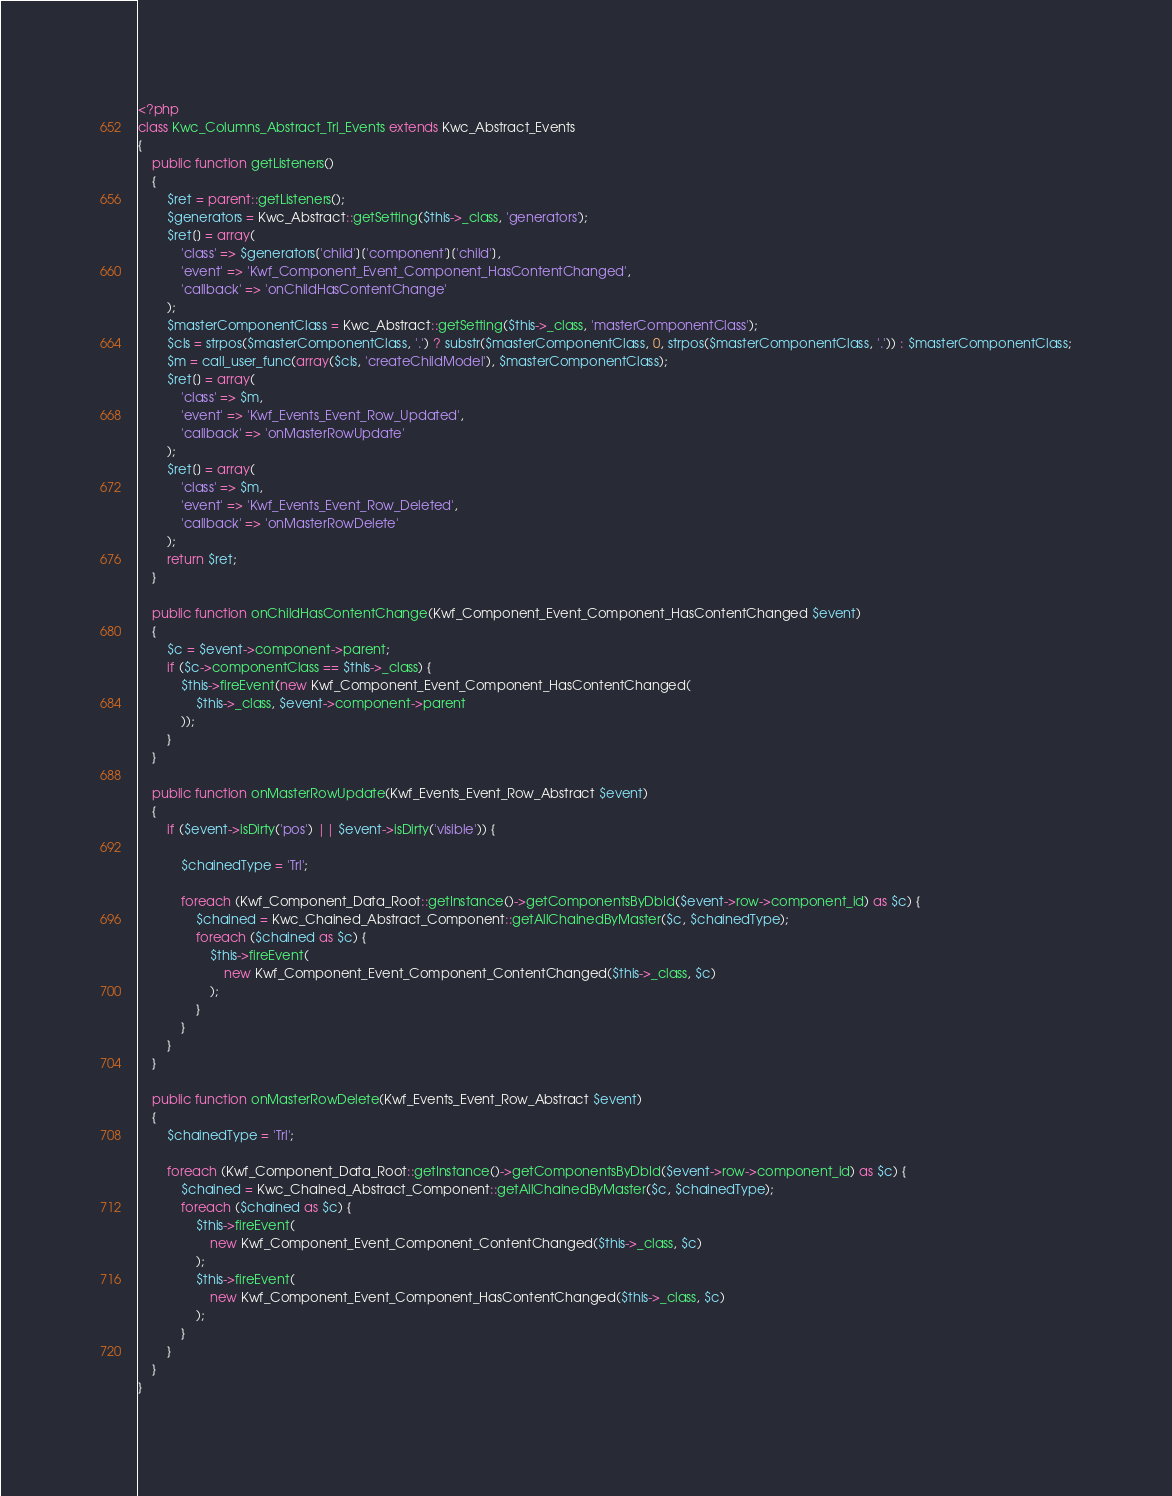Convert code to text. <code><loc_0><loc_0><loc_500><loc_500><_PHP_><?php
class Kwc_Columns_Abstract_Trl_Events extends Kwc_Abstract_Events
{
    public function getListeners()
    {
        $ret = parent::getListeners();
        $generators = Kwc_Abstract::getSetting($this->_class, 'generators');
        $ret[] = array(
            'class' => $generators['child']['component']['child'],
            'event' => 'Kwf_Component_Event_Component_HasContentChanged',
            'callback' => 'onChildHasContentChange'
        );
        $masterComponentClass = Kwc_Abstract::getSetting($this->_class, 'masterComponentClass');
        $cls = strpos($masterComponentClass, '.') ? substr($masterComponentClass, 0, strpos($masterComponentClass, '.')) : $masterComponentClass;
        $m = call_user_func(array($cls, 'createChildModel'), $masterComponentClass);
        $ret[] = array(
            'class' => $m,
            'event' => 'Kwf_Events_Event_Row_Updated',
            'callback' => 'onMasterRowUpdate'
        );
        $ret[] = array(
            'class' => $m,
            'event' => 'Kwf_Events_Event_Row_Deleted',
            'callback' => 'onMasterRowDelete'
        );
        return $ret;
    }

    public function onChildHasContentChange(Kwf_Component_Event_Component_HasContentChanged $event)
    {
        $c = $event->component->parent;
        if ($c->componentClass == $this->_class) {
            $this->fireEvent(new Kwf_Component_Event_Component_HasContentChanged(
                $this->_class, $event->component->parent
            ));
        }
    }

    public function onMasterRowUpdate(Kwf_Events_Event_Row_Abstract $event)
    {
        if ($event->isDirty('pos') || $event->isDirty('visible')) {

            $chainedType = 'Trl';

            foreach (Kwf_Component_Data_Root::getInstance()->getComponentsByDbId($event->row->component_id) as $c) {
                $chained = Kwc_Chained_Abstract_Component::getAllChainedByMaster($c, $chainedType);
                foreach ($chained as $c) {
                    $this->fireEvent(
                        new Kwf_Component_Event_Component_ContentChanged($this->_class, $c)
                    );
                }
            }
        }
    }

    public function onMasterRowDelete(Kwf_Events_Event_Row_Abstract $event)
    {
        $chainedType = 'Trl';

        foreach (Kwf_Component_Data_Root::getInstance()->getComponentsByDbId($event->row->component_id) as $c) {
            $chained = Kwc_Chained_Abstract_Component::getAllChainedByMaster($c, $chainedType);
            foreach ($chained as $c) {
                $this->fireEvent(
                    new Kwf_Component_Event_Component_ContentChanged($this->_class, $c)
                );
                $this->fireEvent(
                    new Kwf_Component_Event_Component_HasContentChanged($this->_class, $c)
                );
            }
        }
    }
}
</code> 